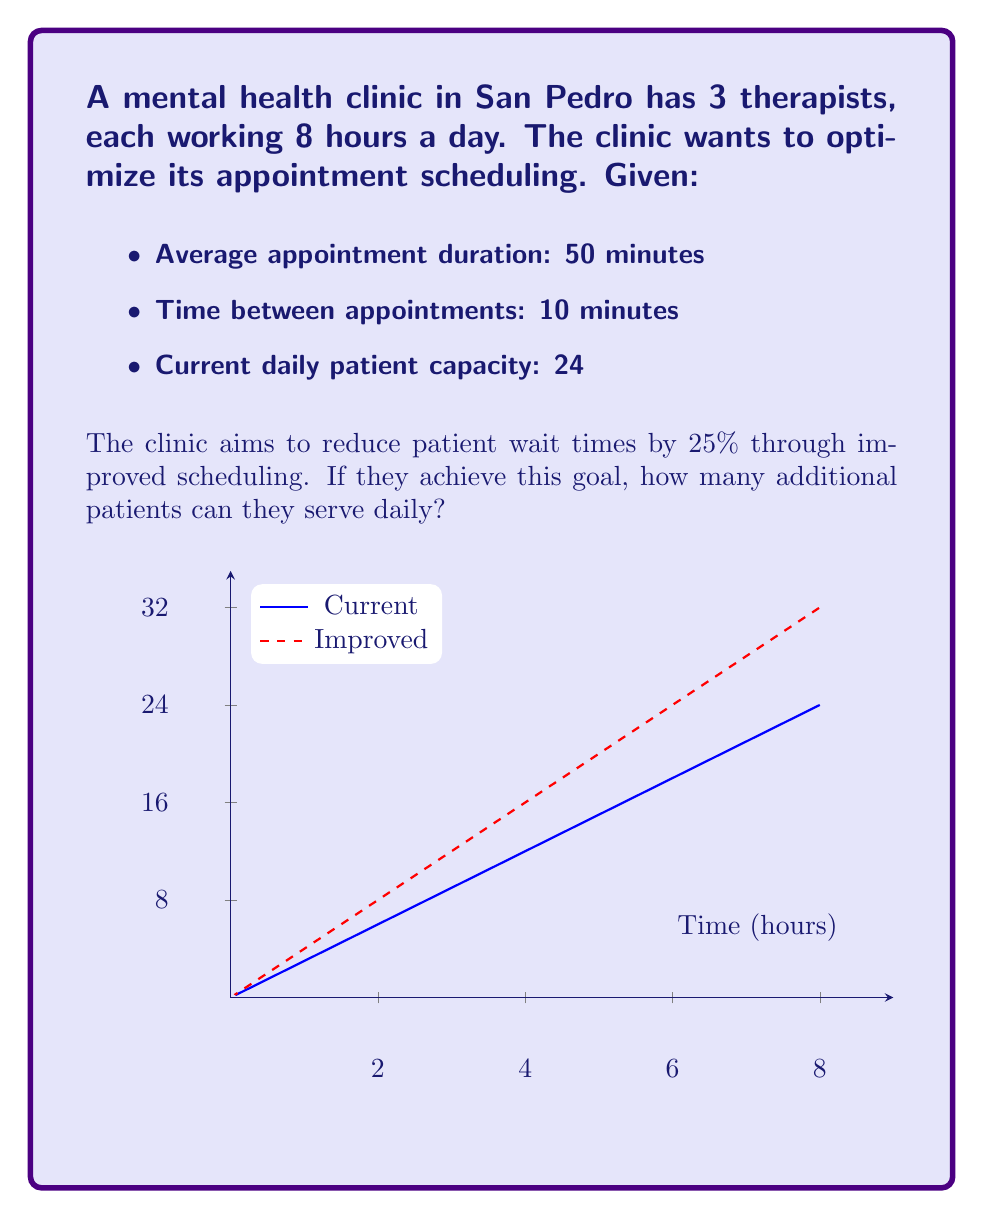Solve this math problem. Let's approach this step-by-step:

1) First, calculate the current time per patient:
   $$\text{Time per patient} = 50 \text{ minutes} + 10 \text{ minutes} = 60 \text{ minutes}$$

2) Calculate the total available time:
   $$\text{Total time} = 3 \text{ therapists} \times 8 \text{ hours} \times 60 \text{ minutes/hour} = 1440 \text{ minutes}$$

3) Verify the current daily capacity:
   $$\text{Current capacity} = \frac{1440 \text{ minutes}}{60 \text{ minutes/patient}} = 24 \text{ patients}$$

4) To reduce wait times by 25%, we need to reduce the time per patient by 25%:
   $$\text{New time per patient} = 60 \text{ minutes} \times (1 - 0.25) = 45 \text{ minutes}$$

5) Calculate the new daily capacity:
   $$\text{New capacity} = \frac{1440 \text{ minutes}}{45 \text{ minutes/patient}} = 32 \text{ patients}$$

6) Find the increase in daily capacity:
   $$\text{Additional patients} = 32 - 24 = 8 \text{ patients}$$

Therefore, by reducing patient wait times by 25%, the clinic can serve 8 additional patients daily.
Answer: 8 patients 